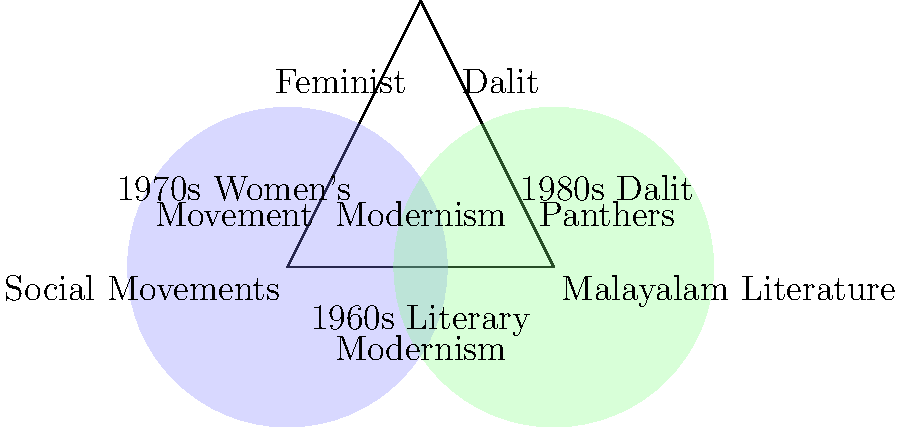Analyze the Venn diagram depicting the intersection of social movements and Malayalam literature. Which literary movement, represented in the overlapping area, was significantly influenced by both feminist and Dalit movements in Kerala during the late 20th century? To answer this question, let's analyze the Venn diagram step-by-step:

1. The diagram shows two intersecting circles representing "Social Movements" and "Malayalam Literature."

2. In the overlapping area, we can see three literary movements: Feminist, Dalit, and Modernism.

3. The diagram also provides historical context:
   - 1970s Women's Movement (under Social Movements)
   - 1980s Dalit Panthers (under Social Movements)
   - 1960s Literary Modernism (under Malayalam Literature)

4. The question asks about a literary movement influenced by both feminist and Dalit movements in the late 20th century.

5. Considering the timeline:
   - The Women's Movement emerged in the 1970s
   - The Dalit Panthers movement gained prominence in the 1980s

6. Both these social movements occurred after the 1960s Literary Modernism.

7. In the overlapping area, we see both "Feminist" and "Dalit" literary movements, indicating their influence from the corresponding social movements.

8. Modernism, while present in the overlap, predates these social movements and thus was not significantly influenced by them in the late 20th century.

Therefore, the literary movements that were significantly influenced by both feminist and Dalit social movements in Kerala during the late 20th century are the Feminist and Dalit literary movements in Malayalam literature.
Answer: Feminist and Dalit literary movements 